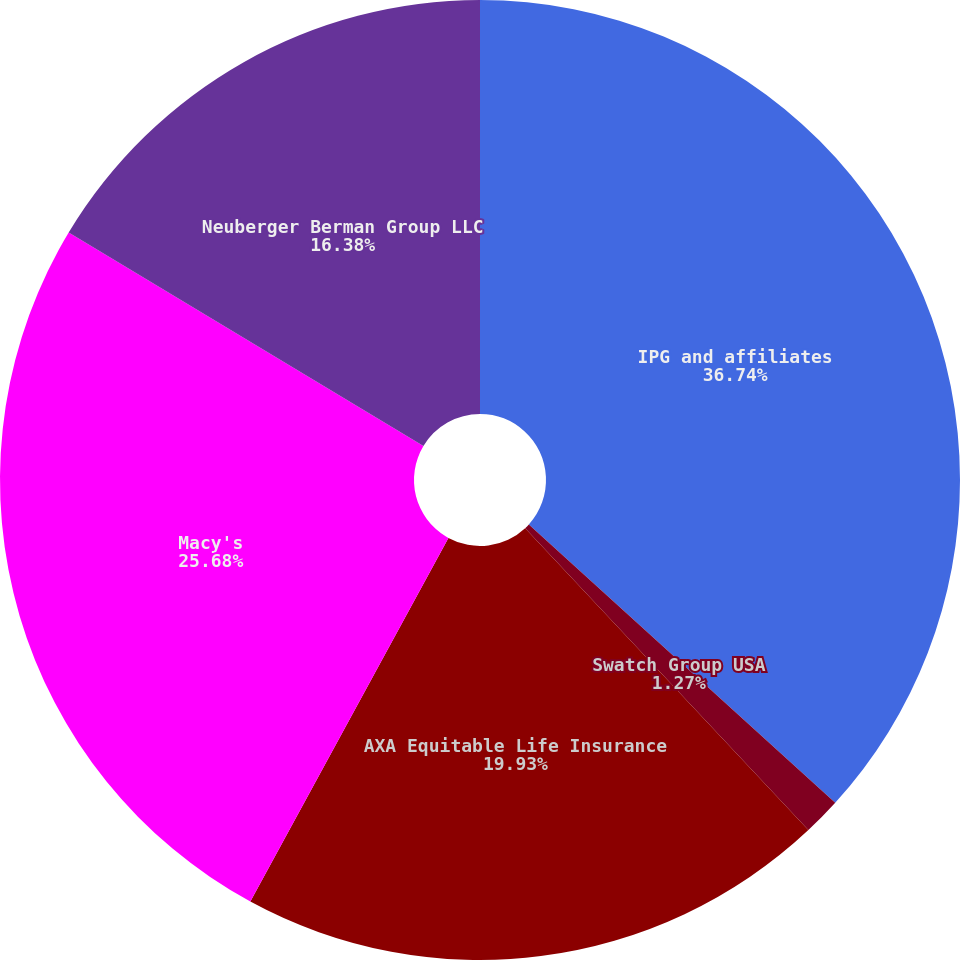Convert chart. <chart><loc_0><loc_0><loc_500><loc_500><pie_chart><fcel>IPG and affiliates<fcel>Swatch Group USA<fcel>AXA Equitable Life Insurance<fcel>Macy's<fcel>Neuberger Berman Group LLC<nl><fcel>36.74%<fcel>1.27%<fcel>19.93%<fcel>25.68%<fcel>16.38%<nl></chart> 